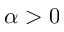Convert formula to latex. <formula><loc_0><loc_0><loc_500><loc_500>\alpha > 0</formula> 